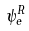Convert formula to latex. <formula><loc_0><loc_0><loc_500><loc_500>\psi _ { e } ^ { R }</formula> 